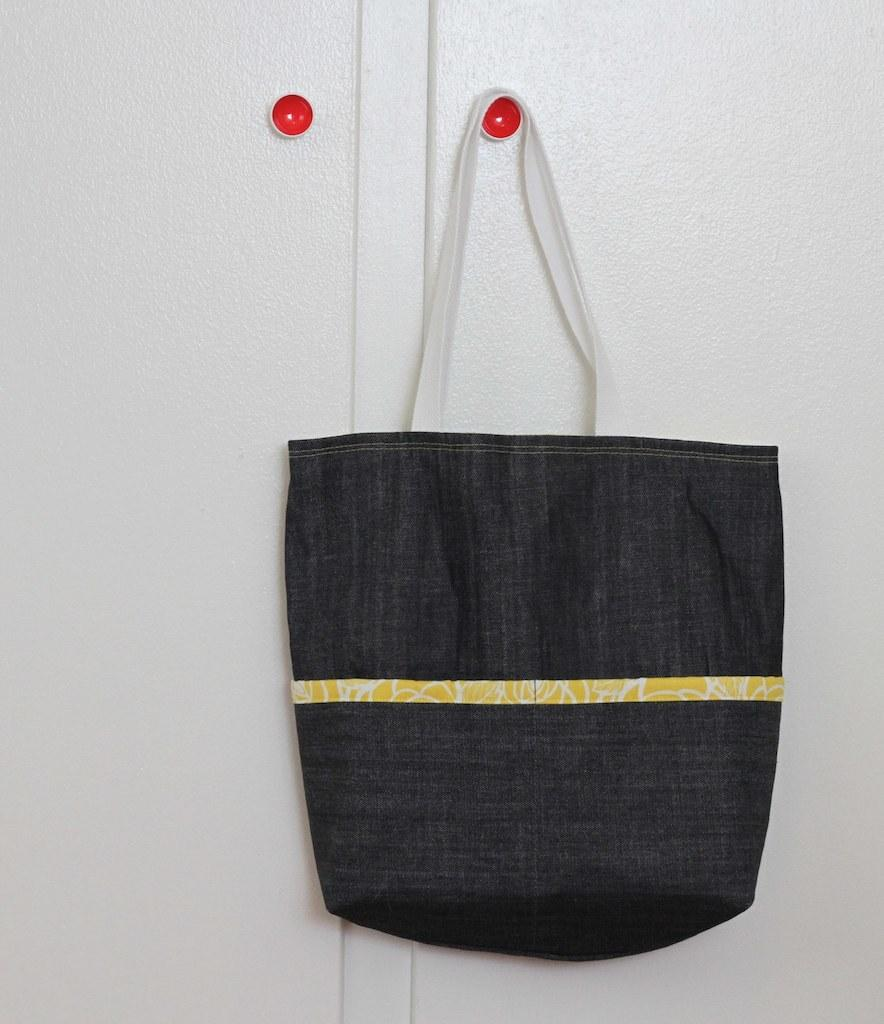What is hanging on the door knob in the image? There is a black bag hanging on a red door knob in the image. What color is the door in the image? The door is off-white in color. Can you describe the relationship between the black bag and the door knob? The black bag is hanging on the red door knob. What type of current can be seen flowing through the basket in the image? There is no basket or current present in the image. 